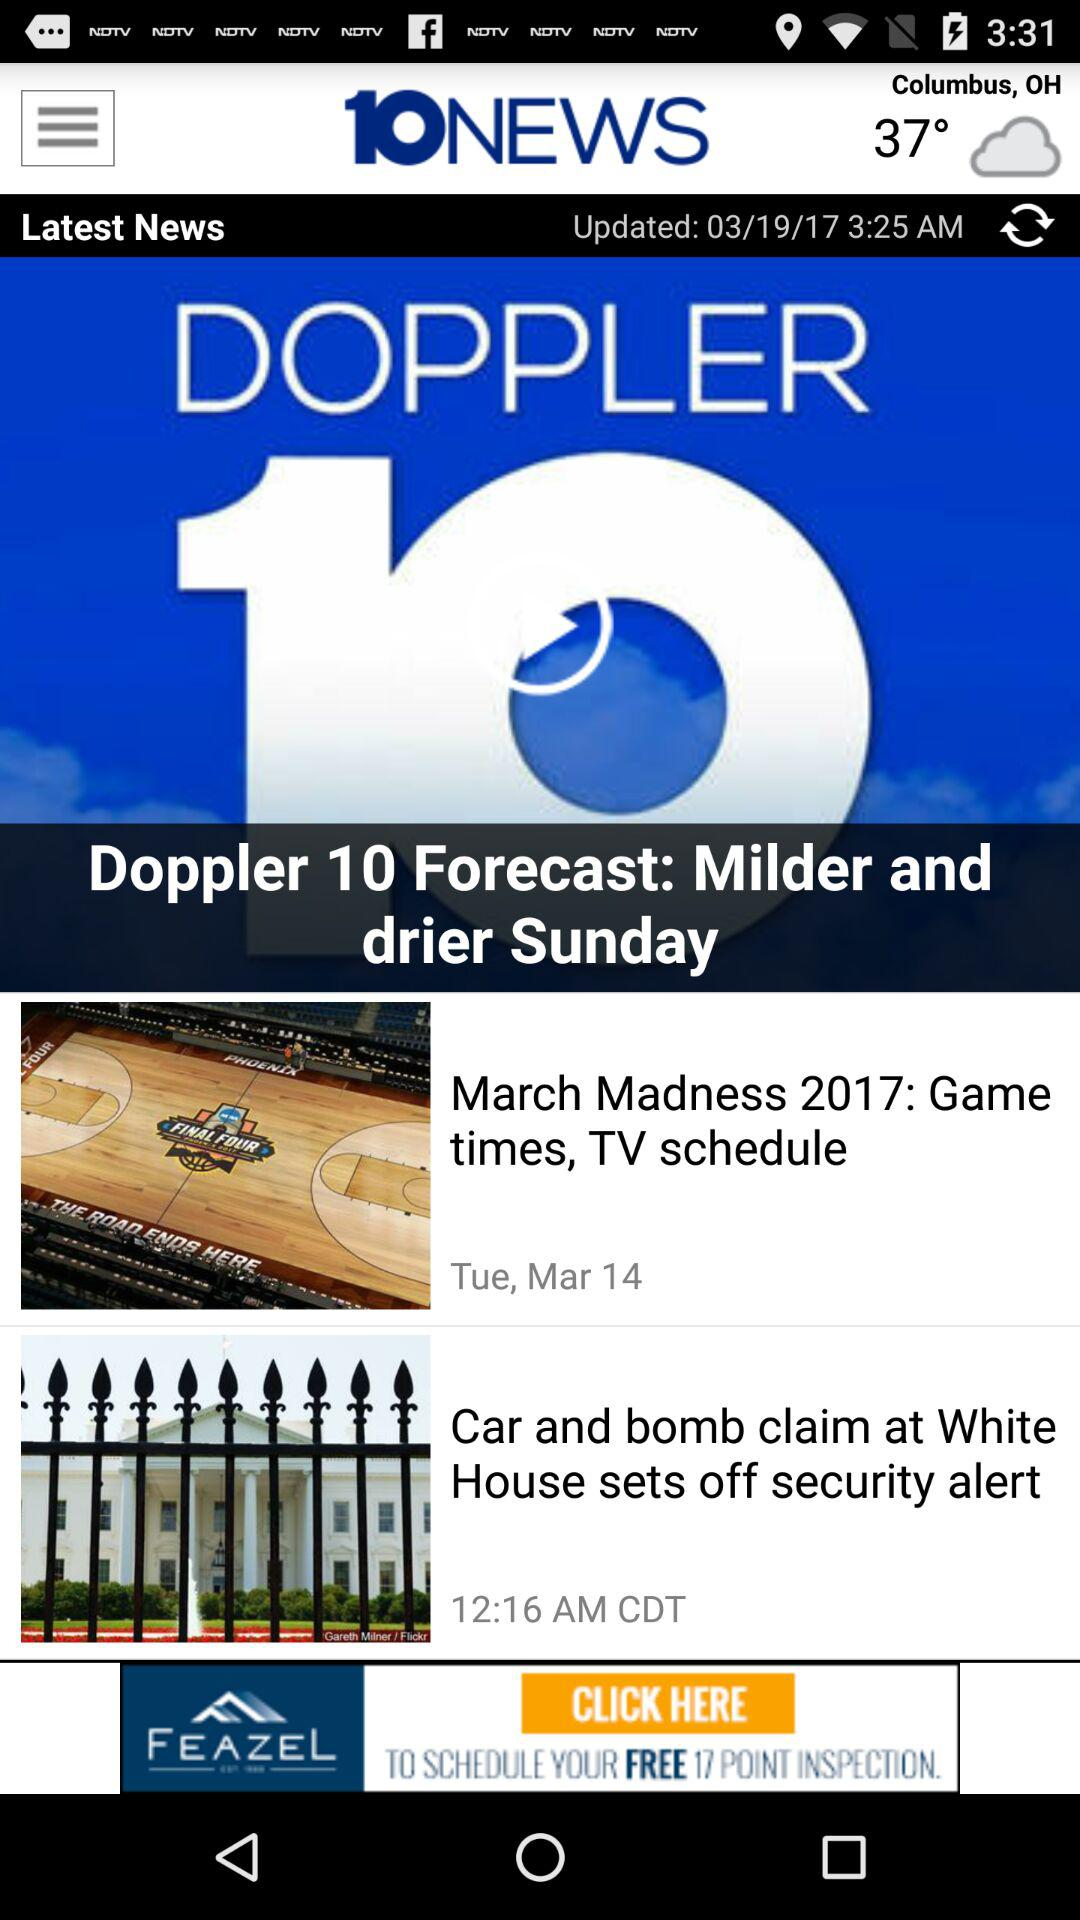What is the shown temperature? The shown temperature is 37°. 